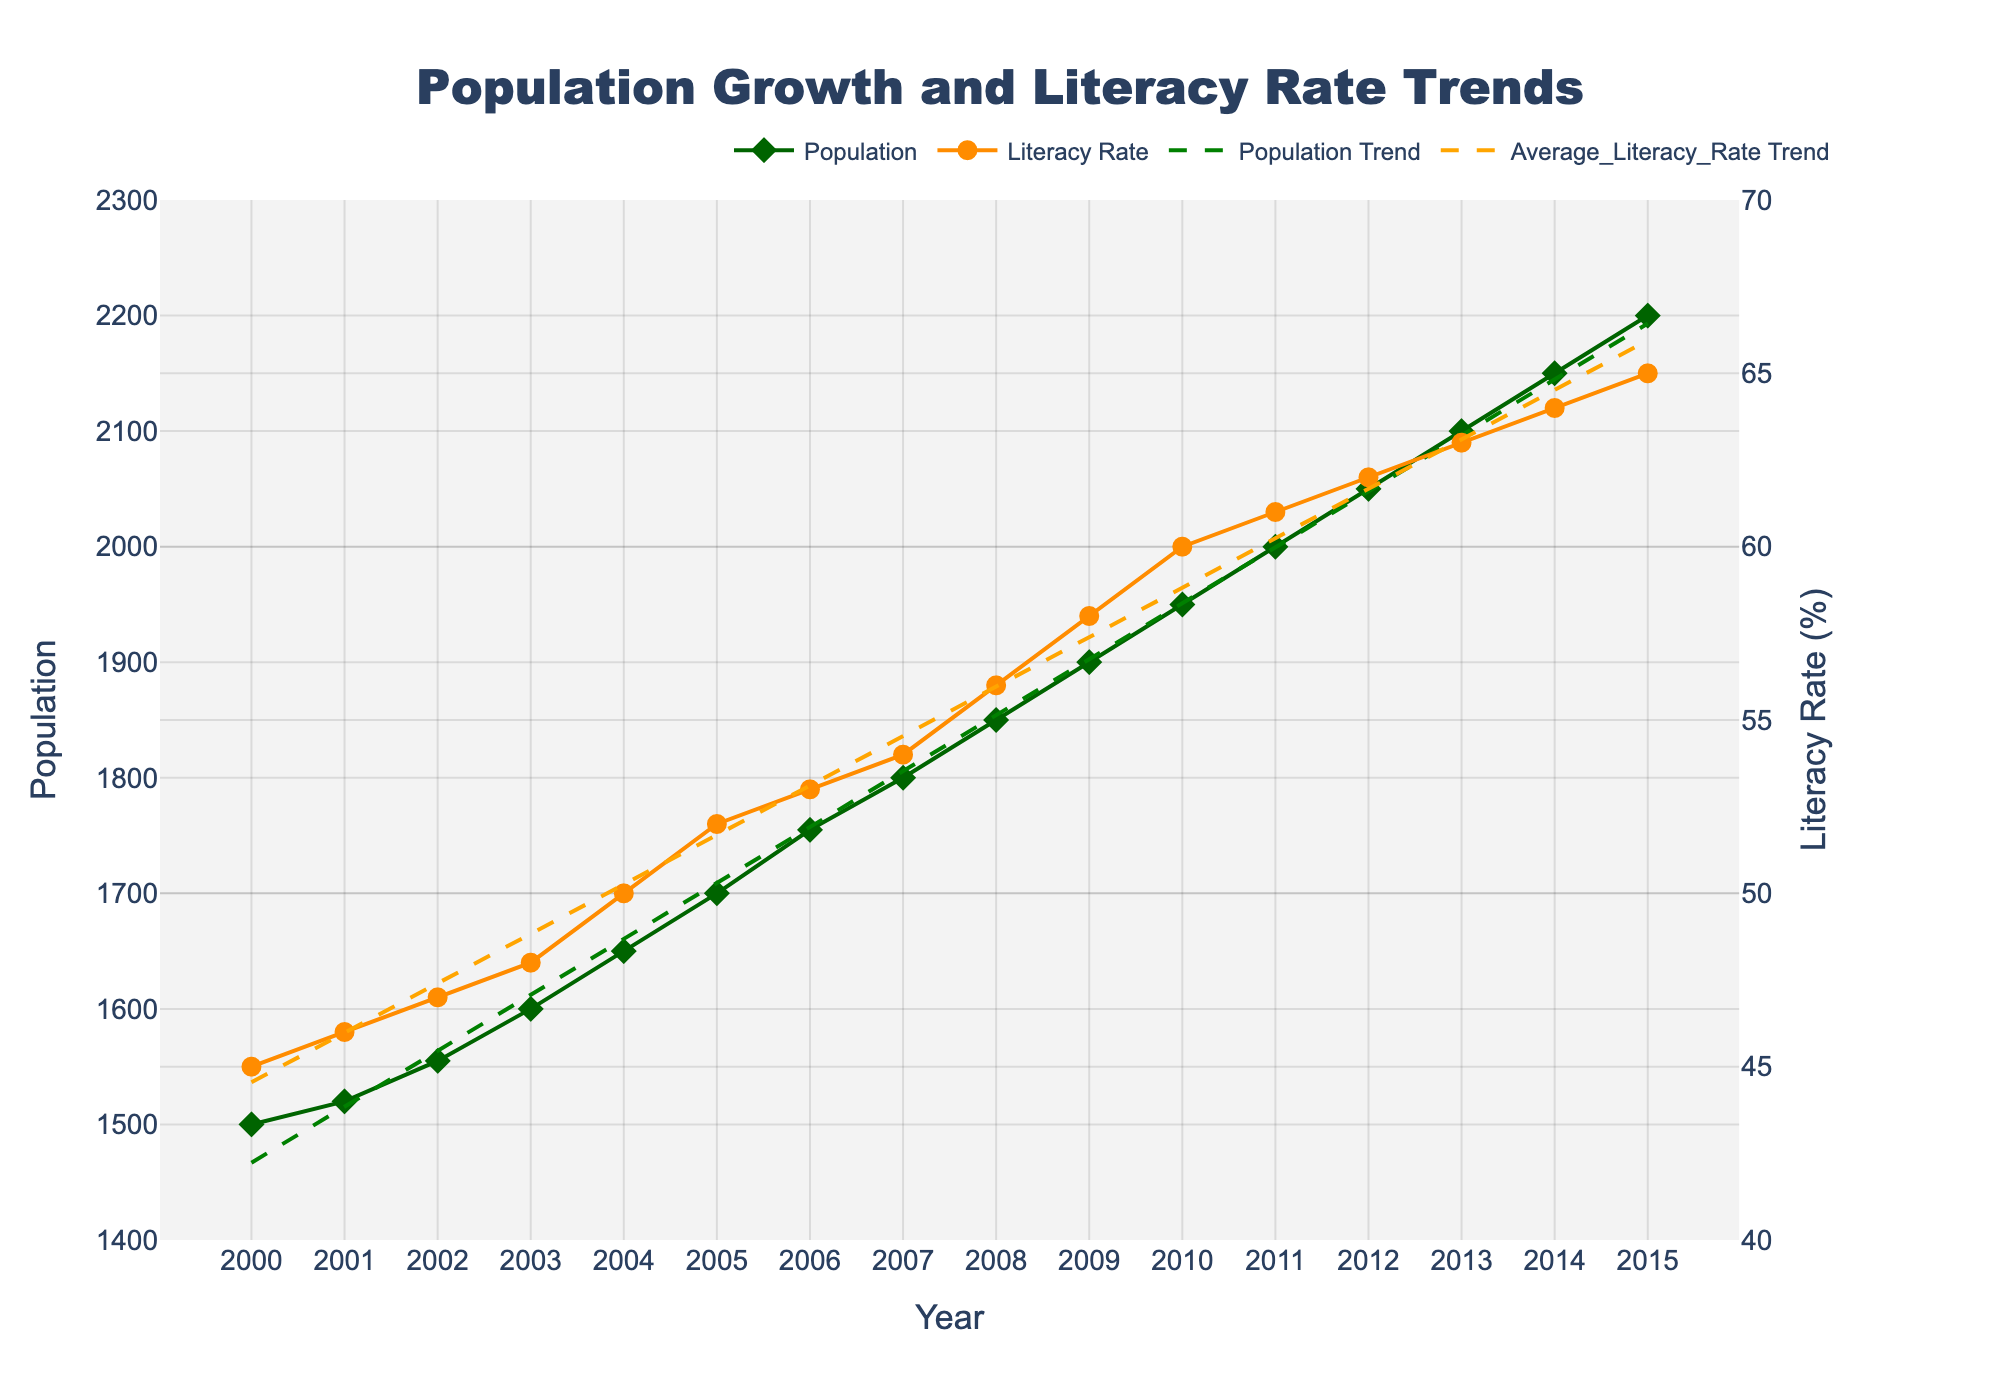What is the title of the figure? The title is displayed at the top of the figure in a large font.
Answer: Population Growth and Literacy Rate Trends How many data points are shown for the Population? Each year from 2000 to 2015 has a corresponding data point for Population, which can be counted.
Answer: 16 What is the range of the Literacy Rate axis? The y-axis for Literacy Rate spans from the minimum to the maximum values indicated on the axis.
Answer: 40% to 70% What was the Population in the year 2009? The scatter plot shows the Population value for each year; locate the data point corresponding to the year 2009.
Answer: 1900 What is the trend in Literacy Rate over the given years? The trend line added to the figure shows the overall direction of the Literacy Rate data points over time.
Answer: Increasing What is the difference in Population between the years 2000 and 2010? Subtract the Population value in 2000 from the Population value in 2010.
Answer: 450 How does the trend in Population compare to the trend in Literacy Rate? Analyze the directions and slopes of the two trend lines displayed on the figure.
Answer: Both are increasing What year had an Average Literacy Rate of 60%? Look at the scatter plot for Literacy Rate and identify the year where the data point is at 60%.
Answer: 2010 By how many units does the Population increase each year on average? Calculate the slope of the Population trend line which represents the average increase per year.
Answer: ~50 Which increased more from 2005 to 2015, the Population or the Average Literacy Rate? Compare the differences in Population and Literacy Rate values between the years 2005 and 2015.
Answer: Literacy Rate 